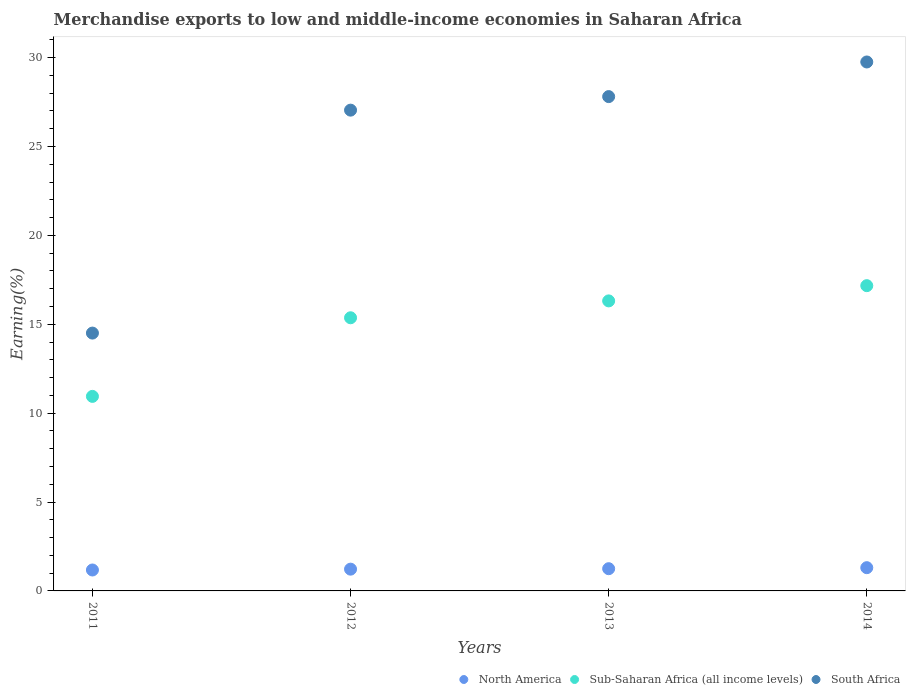What is the percentage of amount earned from merchandise exports in Sub-Saharan Africa (all income levels) in 2014?
Provide a short and direct response. 17.17. Across all years, what is the maximum percentage of amount earned from merchandise exports in South Africa?
Offer a very short reply. 29.76. Across all years, what is the minimum percentage of amount earned from merchandise exports in South Africa?
Make the answer very short. 14.5. What is the total percentage of amount earned from merchandise exports in North America in the graph?
Your response must be concise. 4.96. What is the difference between the percentage of amount earned from merchandise exports in South Africa in 2011 and that in 2014?
Provide a succinct answer. -15.25. What is the difference between the percentage of amount earned from merchandise exports in Sub-Saharan Africa (all income levels) in 2011 and the percentage of amount earned from merchandise exports in South Africa in 2014?
Offer a very short reply. -18.81. What is the average percentage of amount earned from merchandise exports in South Africa per year?
Provide a succinct answer. 24.78. In the year 2014, what is the difference between the percentage of amount earned from merchandise exports in North America and percentage of amount earned from merchandise exports in Sub-Saharan Africa (all income levels)?
Make the answer very short. -15.86. In how many years, is the percentage of amount earned from merchandise exports in North America greater than 10 %?
Your answer should be very brief. 0. What is the ratio of the percentage of amount earned from merchandise exports in Sub-Saharan Africa (all income levels) in 2012 to that in 2013?
Your answer should be compact. 0.94. Is the percentage of amount earned from merchandise exports in North America in 2012 less than that in 2014?
Offer a terse response. Yes. Is the difference between the percentage of amount earned from merchandise exports in North America in 2011 and 2013 greater than the difference between the percentage of amount earned from merchandise exports in Sub-Saharan Africa (all income levels) in 2011 and 2013?
Ensure brevity in your answer.  Yes. What is the difference between the highest and the second highest percentage of amount earned from merchandise exports in South Africa?
Ensure brevity in your answer.  1.95. What is the difference between the highest and the lowest percentage of amount earned from merchandise exports in North America?
Give a very brief answer. 0.13. Is the sum of the percentage of amount earned from merchandise exports in South Africa in 2013 and 2014 greater than the maximum percentage of amount earned from merchandise exports in Sub-Saharan Africa (all income levels) across all years?
Keep it short and to the point. Yes. Does the percentage of amount earned from merchandise exports in Sub-Saharan Africa (all income levels) monotonically increase over the years?
Ensure brevity in your answer.  Yes. How many years are there in the graph?
Make the answer very short. 4. Are the values on the major ticks of Y-axis written in scientific E-notation?
Offer a terse response. No. Does the graph contain any zero values?
Ensure brevity in your answer.  No. What is the title of the graph?
Offer a very short reply. Merchandise exports to low and middle-income economies in Saharan Africa. What is the label or title of the X-axis?
Offer a very short reply. Years. What is the label or title of the Y-axis?
Give a very brief answer. Earning(%). What is the Earning(%) in North America in 2011?
Your answer should be very brief. 1.18. What is the Earning(%) in Sub-Saharan Africa (all income levels) in 2011?
Your response must be concise. 10.94. What is the Earning(%) of South Africa in 2011?
Provide a succinct answer. 14.5. What is the Earning(%) of North America in 2012?
Make the answer very short. 1.22. What is the Earning(%) of Sub-Saharan Africa (all income levels) in 2012?
Give a very brief answer. 15.37. What is the Earning(%) in South Africa in 2012?
Provide a succinct answer. 27.05. What is the Earning(%) in North America in 2013?
Offer a very short reply. 1.25. What is the Earning(%) in Sub-Saharan Africa (all income levels) in 2013?
Give a very brief answer. 16.32. What is the Earning(%) of South Africa in 2013?
Keep it short and to the point. 27.81. What is the Earning(%) of North America in 2014?
Your response must be concise. 1.31. What is the Earning(%) in Sub-Saharan Africa (all income levels) in 2014?
Provide a short and direct response. 17.17. What is the Earning(%) of South Africa in 2014?
Provide a succinct answer. 29.76. Across all years, what is the maximum Earning(%) of North America?
Your response must be concise. 1.31. Across all years, what is the maximum Earning(%) in Sub-Saharan Africa (all income levels)?
Your response must be concise. 17.17. Across all years, what is the maximum Earning(%) of South Africa?
Your response must be concise. 29.76. Across all years, what is the minimum Earning(%) of North America?
Ensure brevity in your answer.  1.18. Across all years, what is the minimum Earning(%) of Sub-Saharan Africa (all income levels)?
Your answer should be compact. 10.94. Across all years, what is the minimum Earning(%) of South Africa?
Your answer should be compact. 14.5. What is the total Earning(%) of North America in the graph?
Keep it short and to the point. 4.96. What is the total Earning(%) in Sub-Saharan Africa (all income levels) in the graph?
Your response must be concise. 59.8. What is the total Earning(%) of South Africa in the graph?
Give a very brief answer. 99.11. What is the difference between the Earning(%) of North America in 2011 and that in 2012?
Provide a succinct answer. -0.05. What is the difference between the Earning(%) of Sub-Saharan Africa (all income levels) in 2011 and that in 2012?
Your answer should be very brief. -4.42. What is the difference between the Earning(%) of South Africa in 2011 and that in 2012?
Keep it short and to the point. -12.54. What is the difference between the Earning(%) of North America in 2011 and that in 2013?
Give a very brief answer. -0.07. What is the difference between the Earning(%) in Sub-Saharan Africa (all income levels) in 2011 and that in 2013?
Your answer should be compact. -5.37. What is the difference between the Earning(%) of South Africa in 2011 and that in 2013?
Make the answer very short. -13.3. What is the difference between the Earning(%) of North America in 2011 and that in 2014?
Provide a short and direct response. -0.13. What is the difference between the Earning(%) of Sub-Saharan Africa (all income levels) in 2011 and that in 2014?
Ensure brevity in your answer.  -6.23. What is the difference between the Earning(%) of South Africa in 2011 and that in 2014?
Provide a short and direct response. -15.25. What is the difference between the Earning(%) in North America in 2012 and that in 2013?
Give a very brief answer. -0.03. What is the difference between the Earning(%) in Sub-Saharan Africa (all income levels) in 2012 and that in 2013?
Provide a short and direct response. -0.95. What is the difference between the Earning(%) in South Africa in 2012 and that in 2013?
Make the answer very short. -0.76. What is the difference between the Earning(%) in North America in 2012 and that in 2014?
Ensure brevity in your answer.  -0.08. What is the difference between the Earning(%) in Sub-Saharan Africa (all income levels) in 2012 and that in 2014?
Offer a terse response. -1.81. What is the difference between the Earning(%) of South Africa in 2012 and that in 2014?
Your answer should be compact. -2.71. What is the difference between the Earning(%) of North America in 2013 and that in 2014?
Offer a terse response. -0.06. What is the difference between the Earning(%) in Sub-Saharan Africa (all income levels) in 2013 and that in 2014?
Your response must be concise. -0.86. What is the difference between the Earning(%) of South Africa in 2013 and that in 2014?
Make the answer very short. -1.95. What is the difference between the Earning(%) in North America in 2011 and the Earning(%) in Sub-Saharan Africa (all income levels) in 2012?
Your response must be concise. -14.19. What is the difference between the Earning(%) of North America in 2011 and the Earning(%) of South Africa in 2012?
Keep it short and to the point. -25.87. What is the difference between the Earning(%) in Sub-Saharan Africa (all income levels) in 2011 and the Earning(%) in South Africa in 2012?
Provide a short and direct response. -16.1. What is the difference between the Earning(%) in North America in 2011 and the Earning(%) in Sub-Saharan Africa (all income levels) in 2013?
Your answer should be very brief. -15.14. What is the difference between the Earning(%) in North America in 2011 and the Earning(%) in South Africa in 2013?
Your answer should be very brief. -26.63. What is the difference between the Earning(%) in Sub-Saharan Africa (all income levels) in 2011 and the Earning(%) in South Africa in 2013?
Offer a terse response. -16.86. What is the difference between the Earning(%) in North America in 2011 and the Earning(%) in Sub-Saharan Africa (all income levels) in 2014?
Your response must be concise. -15.99. What is the difference between the Earning(%) of North America in 2011 and the Earning(%) of South Africa in 2014?
Offer a very short reply. -28.58. What is the difference between the Earning(%) in Sub-Saharan Africa (all income levels) in 2011 and the Earning(%) in South Africa in 2014?
Provide a succinct answer. -18.81. What is the difference between the Earning(%) of North America in 2012 and the Earning(%) of Sub-Saharan Africa (all income levels) in 2013?
Make the answer very short. -15.09. What is the difference between the Earning(%) in North America in 2012 and the Earning(%) in South Africa in 2013?
Provide a short and direct response. -26.58. What is the difference between the Earning(%) of Sub-Saharan Africa (all income levels) in 2012 and the Earning(%) of South Africa in 2013?
Offer a very short reply. -12.44. What is the difference between the Earning(%) in North America in 2012 and the Earning(%) in Sub-Saharan Africa (all income levels) in 2014?
Your answer should be very brief. -15.95. What is the difference between the Earning(%) in North America in 2012 and the Earning(%) in South Africa in 2014?
Make the answer very short. -28.53. What is the difference between the Earning(%) of Sub-Saharan Africa (all income levels) in 2012 and the Earning(%) of South Africa in 2014?
Your answer should be compact. -14.39. What is the difference between the Earning(%) of North America in 2013 and the Earning(%) of Sub-Saharan Africa (all income levels) in 2014?
Offer a very short reply. -15.92. What is the difference between the Earning(%) in North America in 2013 and the Earning(%) in South Africa in 2014?
Ensure brevity in your answer.  -28.51. What is the difference between the Earning(%) in Sub-Saharan Africa (all income levels) in 2013 and the Earning(%) in South Africa in 2014?
Ensure brevity in your answer.  -13.44. What is the average Earning(%) of North America per year?
Your answer should be very brief. 1.24. What is the average Earning(%) of Sub-Saharan Africa (all income levels) per year?
Your answer should be compact. 14.95. What is the average Earning(%) of South Africa per year?
Give a very brief answer. 24.78. In the year 2011, what is the difference between the Earning(%) of North America and Earning(%) of Sub-Saharan Africa (all income levels)?
Your response must be concise. -9.77. In the year 2011, what is the difference between the Earning(%) of North America and Earning(%) of South Africa?
Ensure brevity in your answer.  -13.33. In the year 2011, what is the difference between the Earning(%) in Sub-Saharan Africa (all income levels) and Earning(%) in South Africa?
Your response must be concise. -3.56. In the year 2012, what is the difference between the Earning(%) of North America and Earning(%) of Sub-Saharan Africa (all income levels)?
Your response must be concise. -14.14. In the year 2012, what is the difference between the Earning(%) in North America and Earning(%) in South Africa?
Offer a very short reply. -25.82. In the year 2012, what is the difference between the Earning(%) of Sub-Saharan Africa (all income levels) and Earning(%) of South Africa?
Ensure brevity in your answer.  -11.68. In the year 2013, what is the difference between the Earning(%) in North America and Earning(%) in Sub-Saharan Africa (all income levels)?
Provide a succinct answer. -15.06. In the year 2013, what is the difference between the Earning(%) of North America and Earning(%) of South Africa?
Make the answer very short. -26.56. In the year 2013, what is the difference between the Earning(%) in Sub-Saharan Africa (all income levels) and Earning(%) in South Africa?
Give a very brief answer. -11.49. In the year 2014, what is the difference between the Earning(%) in North America and Earning(%) in Sub-Saharan Africa (all income levels)?
Keep it short and to the point. -15.86. In the year 2014, what is the difference between the Earning(%) in North America and Earning(%) in South Africa?
Make the answer very short. -28.45. In the year 2014, what is the difference between the Earning(%) of Sub-Saharan Africa (all income levels) and Earning(%) of South Africa?
Offer a terse response. -12.58. What is the ratio of the Earning(%) of North America in 2011 to that in 2012?
Offer a very short reply. 0.96. What is the ratio of the Earning(%) of Sub-Saharan Africa (all income levels) in 2011 to that in 2012?
Provide a succinct answer. 0.71. What is the ratio of the Earning(%) in South Africa in 2011 to that in 2012?
Give a very brief answer. 0.54. What is the ratio of the Earning(%) in North America in 2011 to that in 2013?
Provide a succinct answer. 0.94. What is the ratio of the Earning(%) in Sub-Saharan Africa (all income levels) in 2011 to that in 2013?
Make the answer very short. 0.67. What is the ratio of the Earning(%) of South Africa in 2011 to that in 2013?
Provide a short and direct response. 0.52. What is the ratio of the Earning(%) in North America in 2011 to that in 2014?
Give a very brief answer. 0.9. What is the ratio of the Earning(%) of Sub-Saharan Africa (all income levels) in 2011 to that in 2014?
Ensure brevity in your answer.  0.64. What is the ratio of the Earning(%) of South Africa in 2011 to that in 2014?
Your answer should be very brief. 0.49. What is the ratio of the Earning(%) in North America in 2012 to that in 2013?
Offer a terse response. 0.98. What is the ratio of the Earning(%) of Sub-Saharan Africa (all income levels) in 2012 to that in 2013?
Provide a short and direct response. 0.94. What is the ratio of the Earning(%) of South Africa in 2012 to that in 2013?
Provide a short and direct response. 0.97. What is the ratio of the Earning(%) in North America in 2012 to that in 2014?
Your answer should be very brief. 0.94. What is the ratio of the Earning(%) in Sub-Saharan Africa (all income levels) in 2012 to that in 2014?
Offer a terse response. 0.89. What is the ratio of the Earning(%) of South Africa in 2012 to that in 2014?
Give a very brief answer. 0.91. What is the ratio of the Earning(%) of North America in 2013 to that in 2014?
Keep it short and to the point. 0.96. What is the ratio of the Earning(%) in Sub-Saharan Africa (all income levels) in 2013 to that in 2014?
Your response must be concise. 0.95. What is the ratio of the Earning(%) in South Africa in 2013 to that in 2014?
Keep it short and to the point. 0.93. What is the difference between the highest and the second highest Earning(%) of North America?
Offer a terse response. 0.06. What is the difference between the highest and the second highest Earning(%) of Sub-Saharan Africa (all income levels)?
Give a very brief answer. 0.86. What is the difference between the highest and the second highest Earning(%) in South Africa?
Ensure brevity in your answer.  1.95. What is the difference between the highest and the lowest Earning(%) in North America?
Your response must be concise. 0.13. What is the difference between the highest and the lowest Earning(%) in Sub-Saharan Africa (all income levels)?
Make the answer very short. 6.23. What is the difference between the highest and the lowest Earning(%) in South Africa?
Your answer should be very brief. 15.25. 